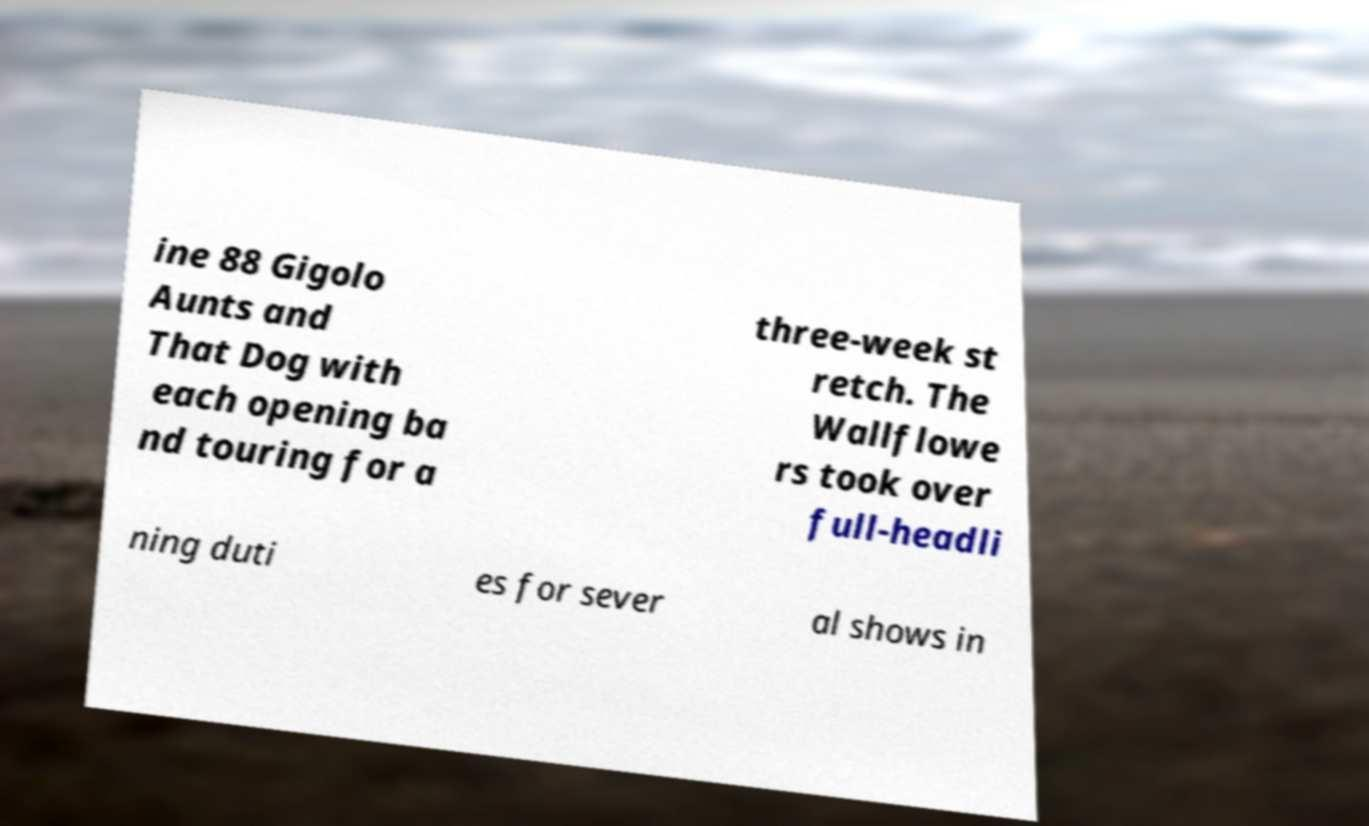Could you assist in decoding the text presented in this image and type it out clearly? ine 88 Gigolo Aunts and That Dog with each opening ba nd touring for a three-week st retch. The Wallflowe rs took over full-headli ning duti es for sever al shows in 